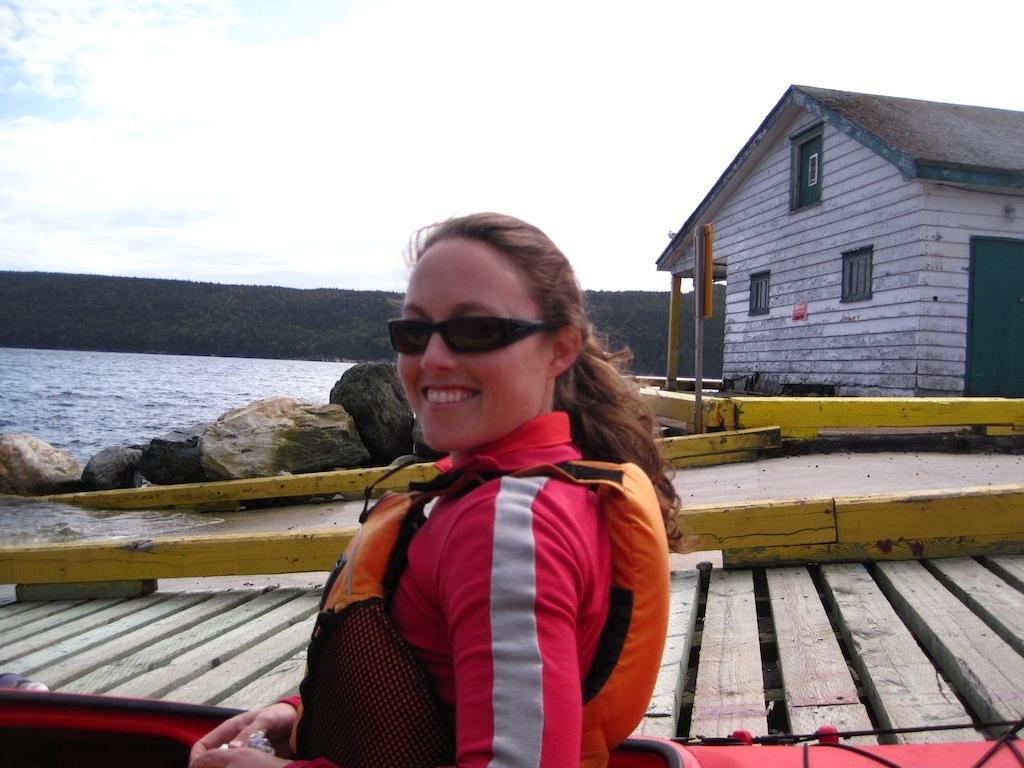Please provide a concise description of this image. In the foreground of the picture there is a woman wearing a life jacket and spectacles. In the center of the picture there are rocks, water, house and dock. In the background it is hill covered with trees. Sky is cloudy. 